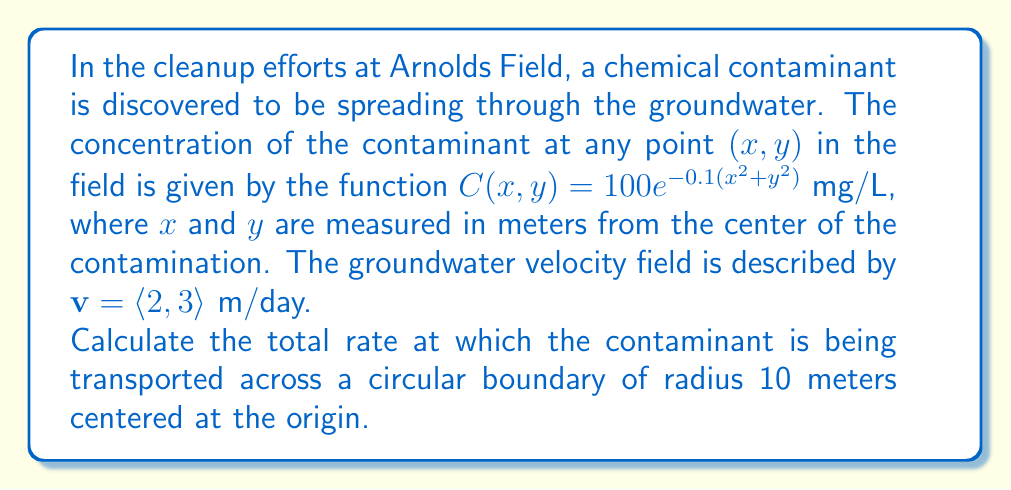Solve this math problem. To solve this problem, we'll use the divergence theorem and concepts from vector calculus and fluid dynamics. Let's break it down step-by-step:

1) The flux of the contaminant is given by the product of the concentration and the velocity field:

   $\mathbf{F} = C(x,y)\mathbf{v} = 100e^{-0.1(x^2+y^2)}\langle 2, 3 \rangle$ mg/(L·day)

2) We need to calculate the flux across a circular boundary. The divergence theorem states that the flux across a closed boundary is equal to the integral of the divergence of the vector field over the enclosed region:

   $\oint_S \mathbf{F} \cdot \mathbf{n} \, dS = \iint_R \nabla \cdot \mathbf{F} \, dA$

3) Let's calculate the divergence of $\mathbf{F}$:

   $\nabla \cdot \mathbf{F} = \frac{\partial}{\partial x}(200e^{-0.1(x^2+y^2)}) + \frac{\partial}{\partial y}(300e^{-0.1(x^2+y^2)})$
   
   $= 200(-0.2x)e^{-0.1(x^2+y^2)} + 300(-0.2y)e^{-0.1(x^2+y^2)}$
   
   $= -40(x+1.5y)e^{-0.1(x^2+y^2)}$

4) Now we need to integrate this over the circular region. It's easier to use polar coordinates:

   $x = r\cos\theta, y = r\sin\theta, dA = r \, dr \, d\theta$

   $\iint_R \nabla \cdot \mathbf{F} \, dA = \int_0^{2\pi} \int_0^{10} -40(r\cos\theta+1.5r\sin\theta)e^{-0.1r^2} r \, dr \, d\theta$

5) Simplify the integral:

   $= -40 \int_0^{2\pi} (\cos\theta+1.5\sin\theta) \, d\theta \int_0^{10} r^2e^{-0.1r^2} \, dr$

6) The $\theta$ integral evaluates to zero over a full period, so the entire expression becomes zero.

This means that the net flux across the circular boundary is zero. However, this doesn't mean there's no transport of the contaminant. It means that the amount entering the circle is equal to the amount leaving it.
Answer: The total rate at which the contaminant is being transported across the circular boundary is 0 mg/day. 